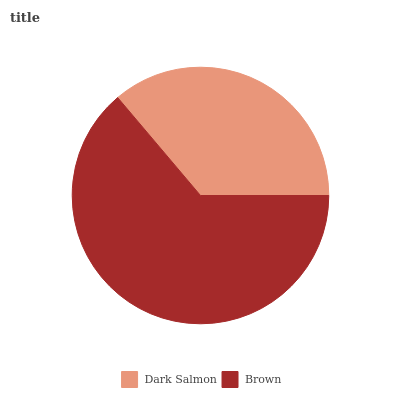Is Dark Salmon the minimum?
Answer yes or no. Yes. Is Brown the maximum?
Answer yes or no. Yes. Is Brown the minimum?
Answer yes or no. No. Is Brown greater than Dark Salmon?
Answer yes or no. Yes. Is Dark Salmon less than Brown?
Answer yes or no. Yes. Is Dark Salmon greater than Brown?
Answer yes or no. No. Is Brown less than Dark Salmon?
Answer yes or no. No. Is Brown the high median?
Answer yes or no. Yes. Is Dark Salmon the low median?
Answer yes or no. Yes. Is Dark Salmon the high median?
Answer yes or no. No. Is Brown the low median?
Answer yes or no. No. 